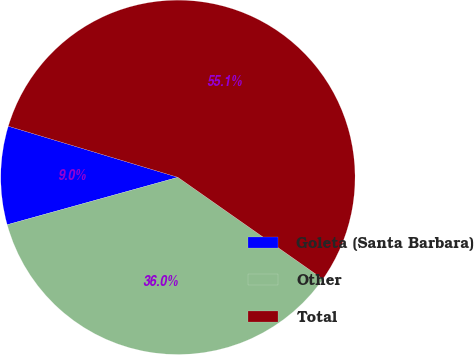Convert chart. <chart><loc_0><loc_0><loc_500><loc_500><pie_chart><fcel>Goleta (Santa Barbara)<fcel>Other<fcel>Total<nl><fcel>8.97%<fcel>35.95%<fcel>55.08%<nl></chart> 